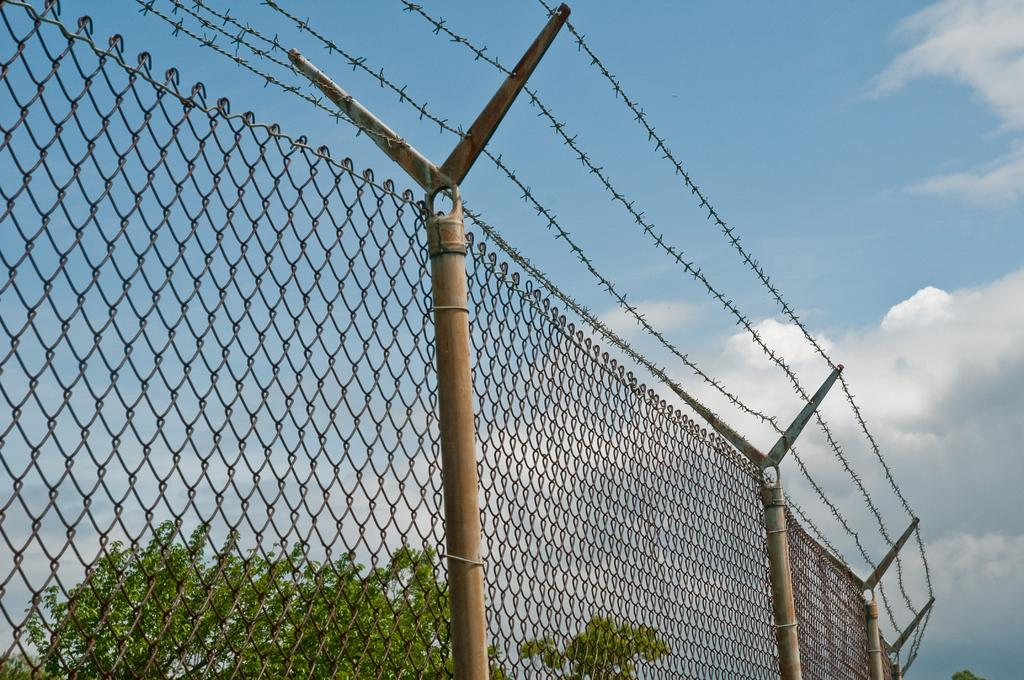What type of fencing is visible in the image? There is a net fencing in the image. What additional feature can be seen on the net fencing? The net fencing has barbed wire. What is located behind the net fencing? There are trees behind the net fencing. What is visible at the top of the image? The sky is visible at the top of the image. What can be observed in the sky? Clouds are present in the sky. What type of plantation can be seen growing behind the net fencing in the image? There is no plantation visible in the image; only trees are present behind the net fencing. 